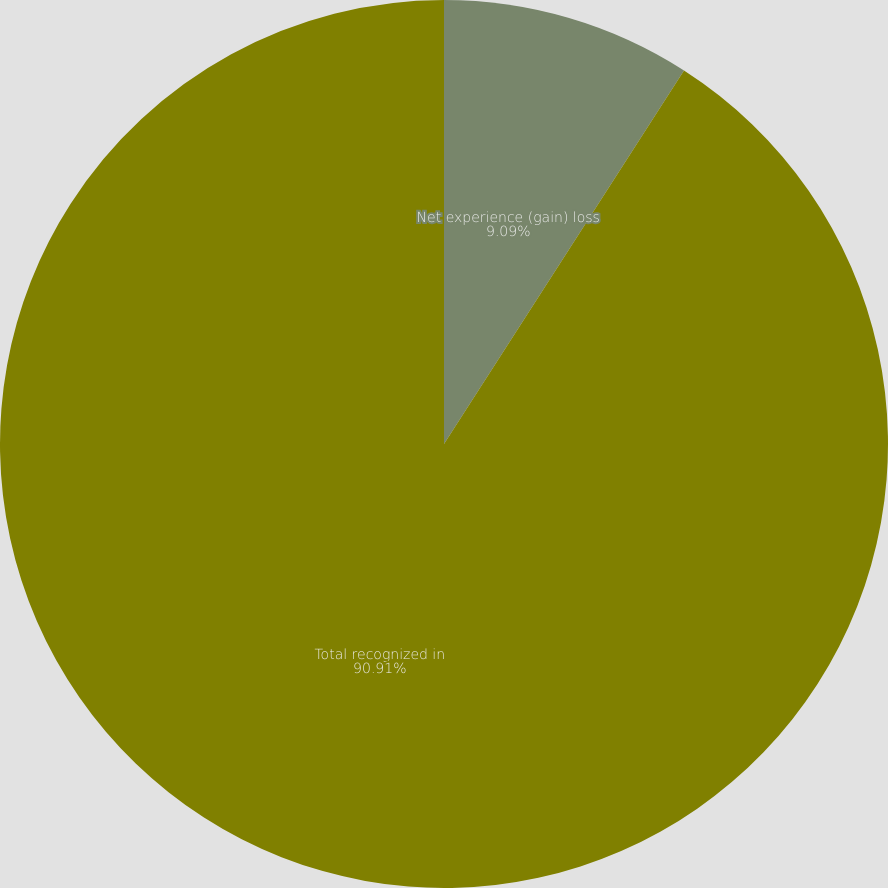Convert chart to OTSL. <chart><loc_0><loc_0><loc_500><loc_500><pie_chart><fcel>Net experience (gain) loss<fcel>Total recognized in<nl><fcel>9.09%<fcel>90.91%<nl></chart> 